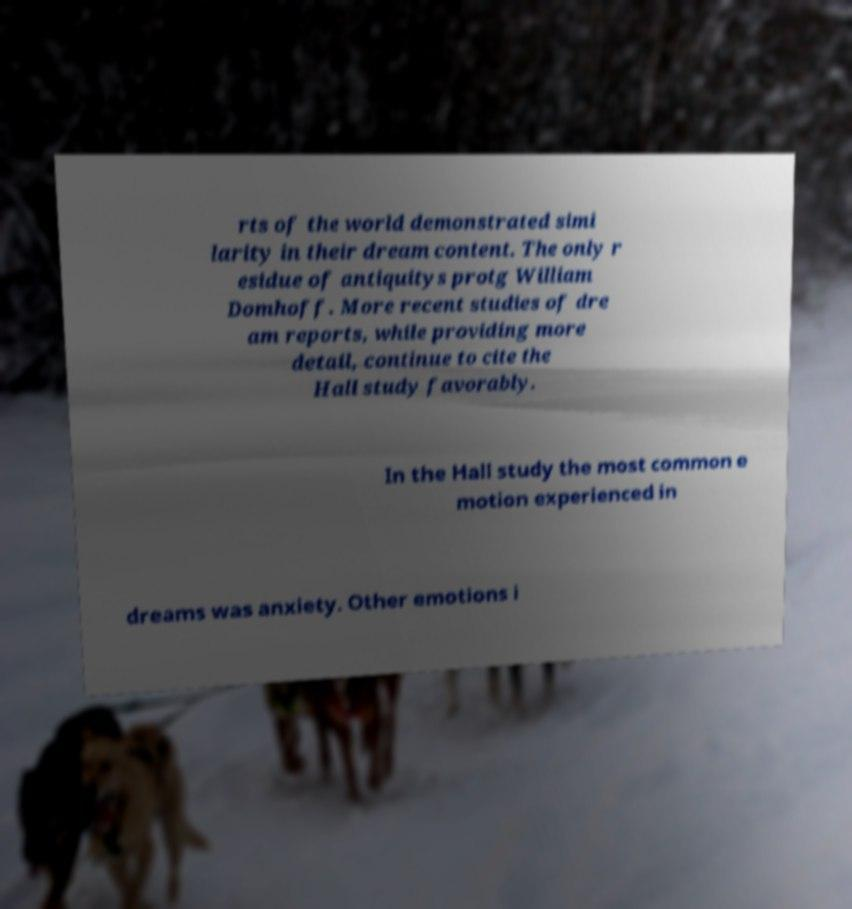Could you assist in decoding the text presented in this image and type it out clearly? rts of the world demonstrated simi larity in their dream content. The only r esidue of antiquitys protg William Domhoff. More recent studies of dre am reports, while providing more detail, continue to cite the Hall study favorably. In the Hall study the most common e motion experienced in dreams was anxiety. Other emotions i 